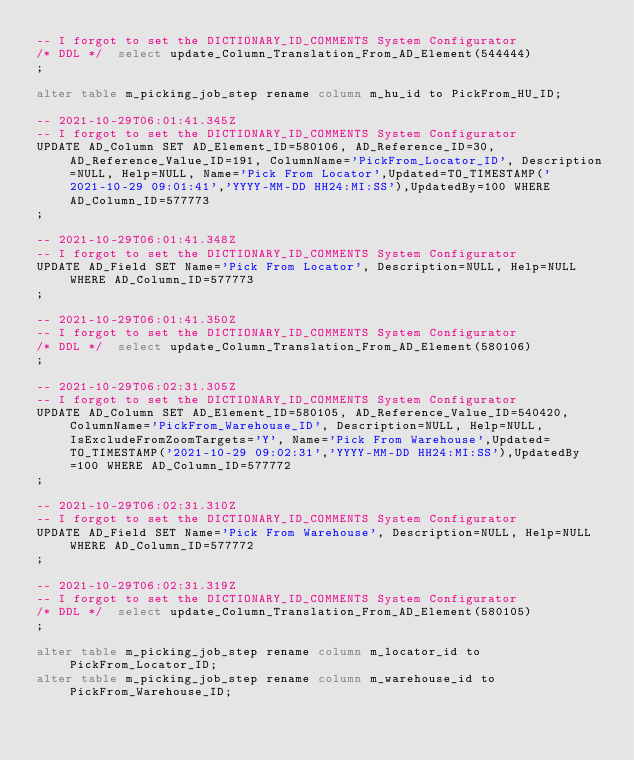<code> <loc_0><loc_0><loc_500><loc_500><_SQL_>-- I forgot to set the DICTIONARY_ID_COMMENTS System Configurator
/* DDL */  select update_Column_Translation_From_AD_Element(544444) 
;

alter table m_picking_job_step rename column m_hu_id to PickFrom_HU_ID;

-- 2021-10-29T06:01:41.345Z
-- I forgot to set the DICTIONARY_ID_COMMENTS System Configurator
UPDATE AD_Column SET AD_Element_ID=580106, AD_Reference_ID=30, AD_Reference_Value_ID=191, ColumnName='PickFrom_Locator_ID', Description=NULL, Help=NULL, Name='Pick From Locator',Updated=TO_TIMESTAMP('2021-10-29 09:01:41','YYYY-MM-DD HH24:MI:SS'),UpdatedBy=100 WHERE AD_Column_ID=577773
;

-- 2021-10-29T06:01:41.348Z
-- I forgot to set the DICTIONARY_ID_COMMENTS System Configurator
UPDATE AD_Field SET Name='Pick From Locator', Description=NULL, Help=NULL WHERE AD_Column_ID=577773
;

-- 2021-10-29T06:01:41.350Z
-- I forgot to set the DICTIONARY_ID_COMMENTS System Configurator
/* DDL */  select update_Column_Translation_From_AD_Element(580106) 
;

-- 2021-10-29T06:02:31.305Z
-- I forgot to set the DICTIONARY_ID_COMMENTS System Configurator
UPDATE AD_Column SET AD_Element_ID=580105, AD_Reference_Value_ID=540420, ColumnName='PickFrom_Warehouse_ID', Description=NULL, Help=NULL, IsExcludeFromZoomTargets='Y', Name='Pick From Warehouse',Updated=TO_TIMESTAMP('2021-10-29 09:02:31','YYYY-MM-DD HH24:MI:SS'),UpdatedBy=100 WHERE AD_Column_ID=577772
;

-- 2021-10-29T06:02:31.310Z
-- I forgot to set the DICTIONARY_ID_COMMENTS System Configurator
UPDATE AD_Field SET Name='Pick From Warehouse', Description=NULL, Help=NULL WHERE AD_Column_ID=577772
;

-- 2021-10-29T06:02:31.319Z
-- I forgot to set the DICTIONARY_ID_COMMENTS System Configurator
/* DDL */  select update_Column_Translation_From_AD_Element(580105) 
;

alter table m_picking_job_step rename column m_locator_id to PickFrom_Locator_ID;
alter table m_picking_job_step rename column m_warehouse_id to PickFrom_Warehouse_ID;


</code> 